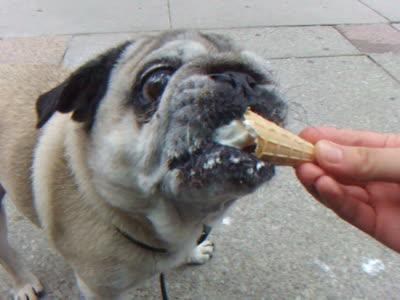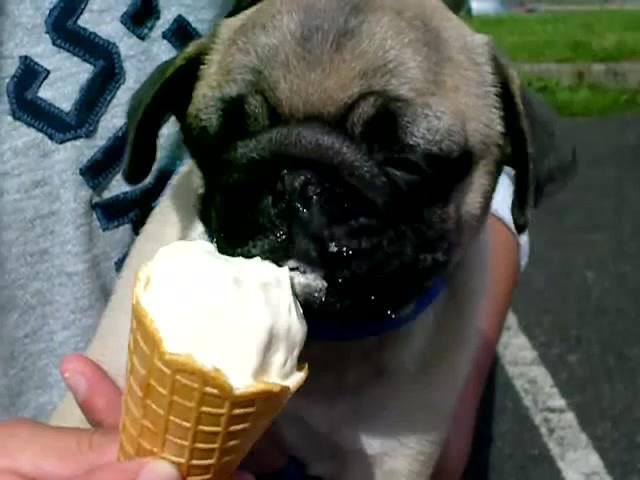The first image is the image on the left, the second image is the image on the right. For the images shown, is this caption "At least 2 dogs are being fed ice cream in a waffle cone that a person is holding." true? Answer yes or no. Yes. The first image is the image on the left, the second image is the image on the right. Given the left and right images, does the statement "There is a dog that is not eating anything." hold true? Answer yes or no. No. 